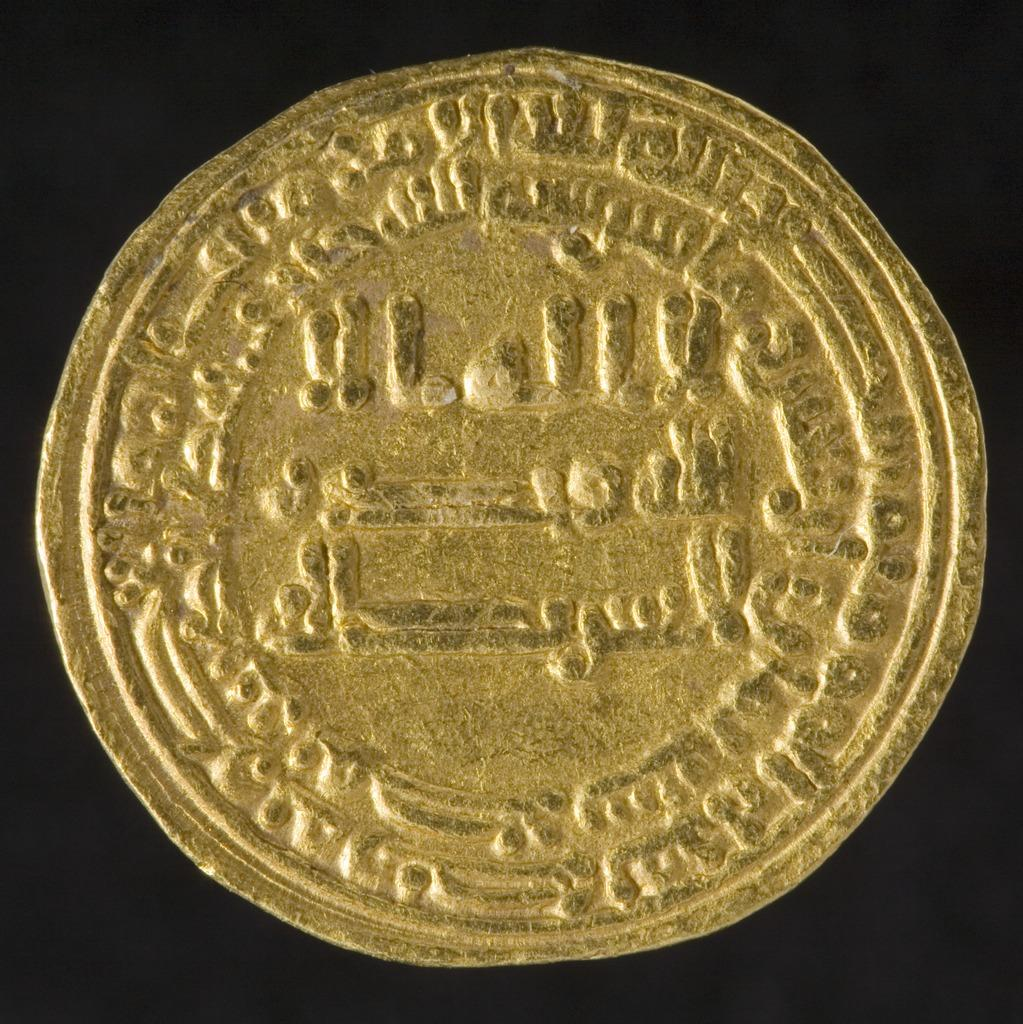What object is the main focus of the image? There is a coin in the image. What can be observed about the overall lighting or color scheme of the image? The background of the image is dark. What type of doll is holding the bat in the image? There is no doll or bat present in the image; it only features a coin. 